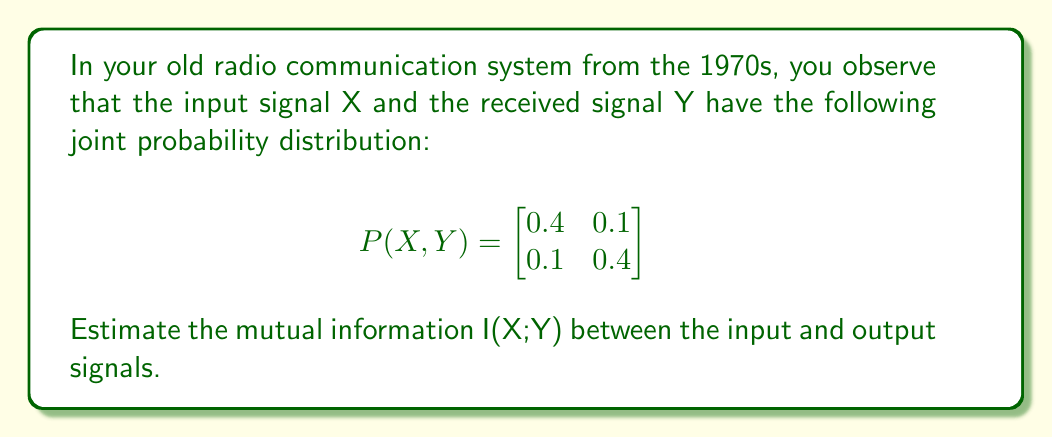Teach me how to tackle this problem. To calculate the mutual information I(X;Y), we'll follow these steps:

1. Calculate the marginal probabilities P(X) and P(Y):
   P(X=0) = 0.4 + 0.1 = 0.5
   P(X=1) = 0.1 + 0.4 = 0.5
   P(Y=0) = 0.4 + 0.1 = 0.5
   P(Y=1) = 0.1 + 0.4 = 0.5

2. Calculate the mutual information using the formula:
   $$I(X;Y) = \sum_{x}\sum_{y} P(x,y) \log_2 \frac{P(x,y)}{P(x)P(y)}$$

3. Compute each term:
   $$0.4 \log_2 \frac{0.4}{0.5 \cdot 0.5} + 0.1 \log_2 \frac{0.1}{0.5 \cdot 0.5} + 0.1 \log_2 \frac{0.1}{0.5 \cdot 0.5} + 0.4 \log_2 \frac{0.4}{0.5 \cdot 0.5}$$

4. Simplify:
   $$0.4 \log_2 1.6 + 0.1 \log_2 0.4 + 0.1 \log_2 0.4 + 0.4 \log_2 1.6$$

5. Calculate:
   $$0.4 \cdot 0.678 + 0.1 \cdot (-1.322) + 0.1 \cdot (-1.322) + 0.4 \cdot 0.678$$
   $$= 0.2712 - 0.1322 - 0.1322 + 0.2712$$
   $$= 0.278 \text{ bits}$$
Answer: The mutual information I(X;Y) is approximately 0.278 bits. 